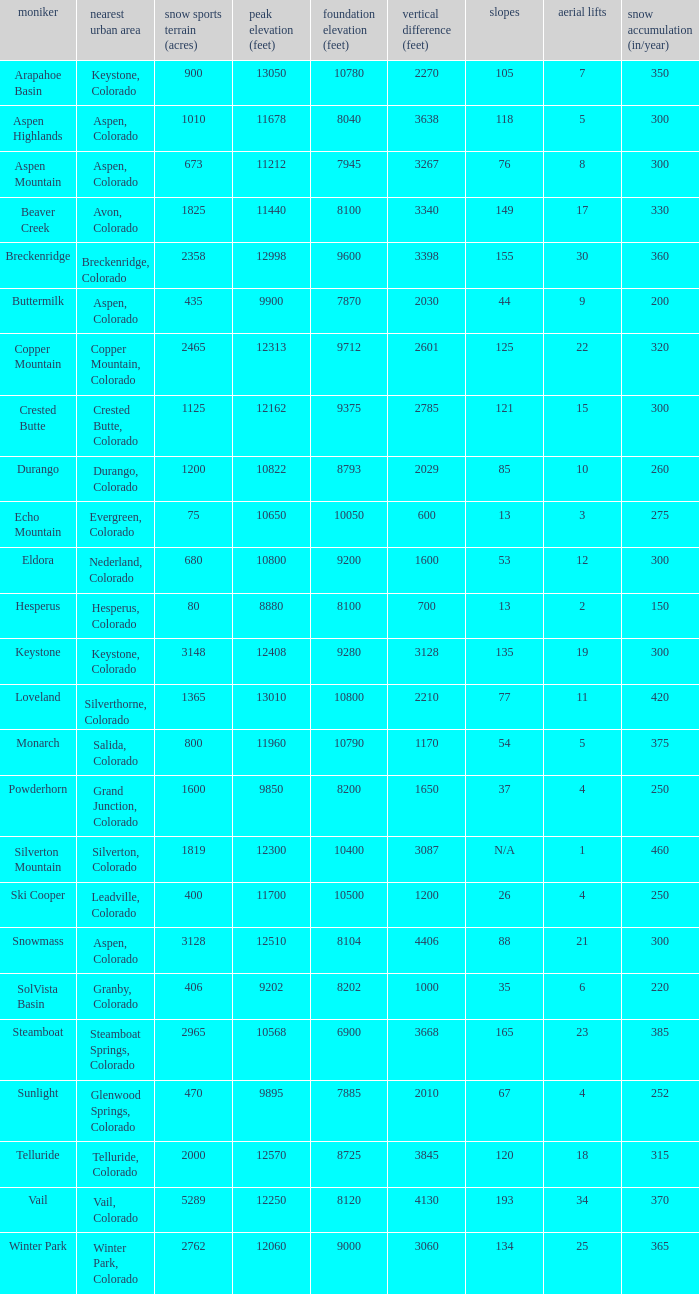How many resorts have 118 runs? 1.0. 